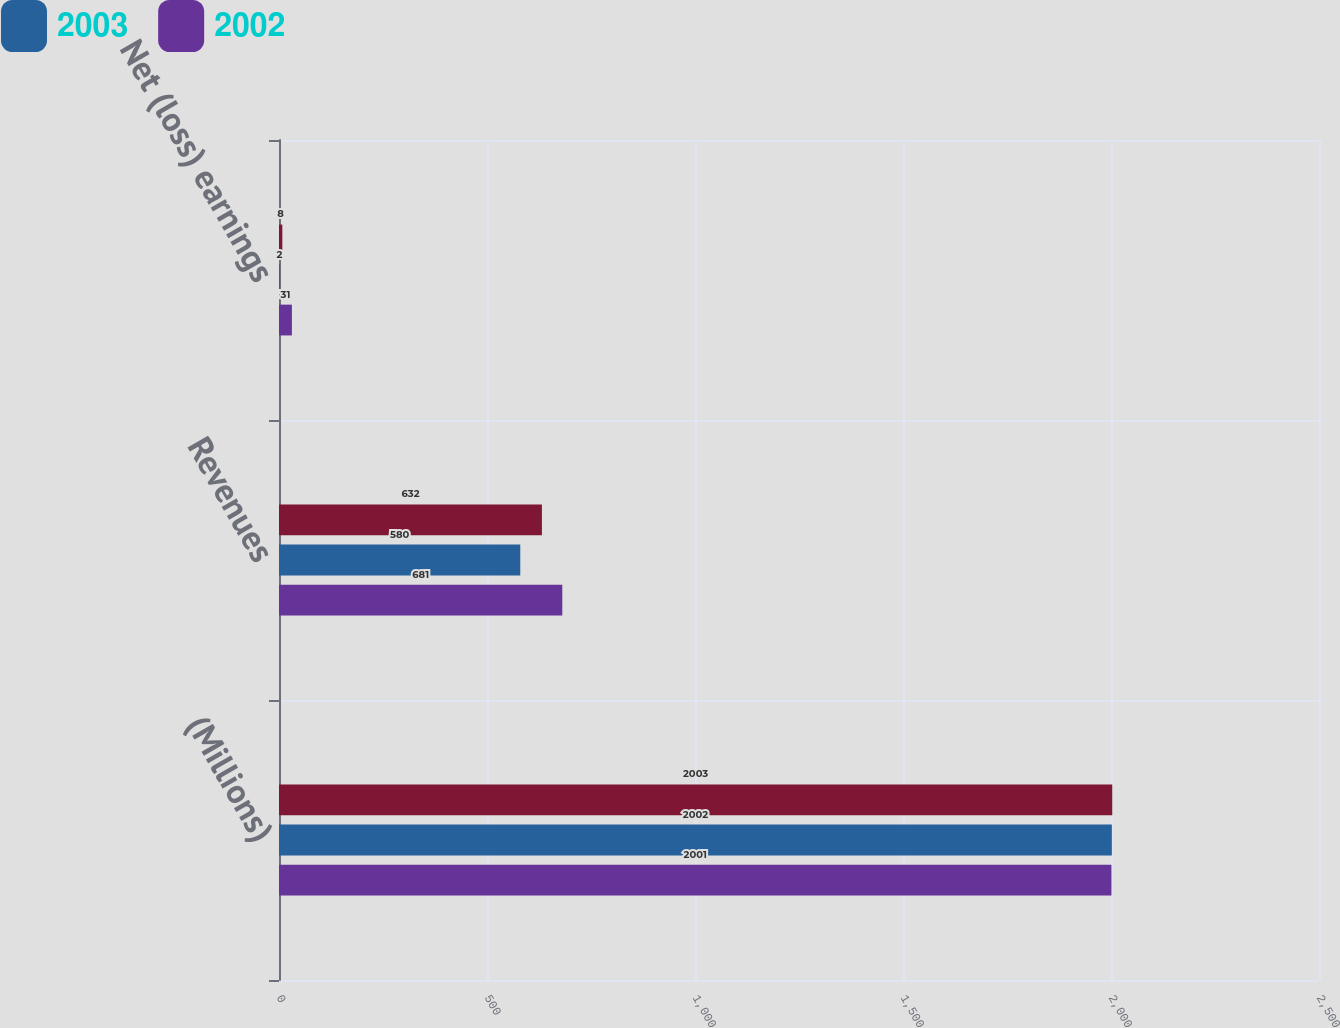Convert chart to OTSL. <chart><loc_0><loc_0><loc_500><loc_500><stacked_bar_chart><ecel><fcel>(Millions)<fcel>Revenues<fcel>Net (loss) earnings<nl><fcel>nan<fcel>2003<fcel>632<fcel>8<nl><fcel>2003<fcel>2002<fcel>580<fcel>2<nl><fcel>2002<fcel>2001<fcel>681<fcel>31<nl></chart> 